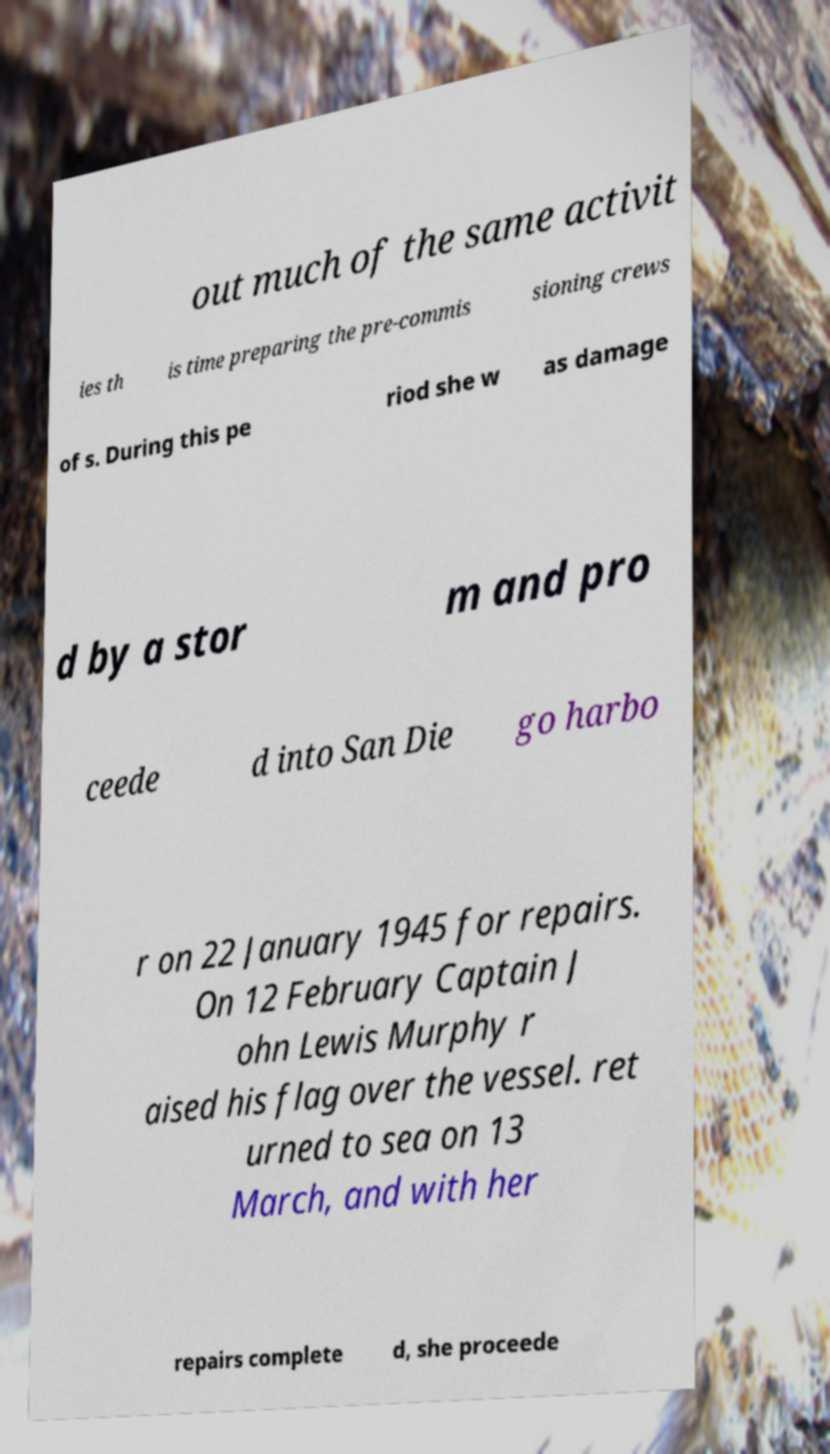Can you accurately transcribe the text from the provided image for me? out much of the same activit ies th is time preparing the pre-commis sioning crews of s. During this pe riod she w as damage d by a stor m and pro ceede d into San Die go harbo r on 22 January 1945 for repairs. On 12 February Captain J ohn Lewis Murphy r aised his flag over the vessel. ret urned to sea on 13 March, and with her repairs complete d, she proceede 